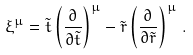Convert formula to latex. <formula><loc_0><loc_0><loc_500><loc_500>\xi ^ { \mu } = \tilde { t } \left ( \frac { \partial } { \partial \tilde { t } } \right ) ^ { \mu } - \tilde { r } \left ( \frac { \partial } { \partial \tilde { r } } \right ) ^ { \mu } \, .</formula> 